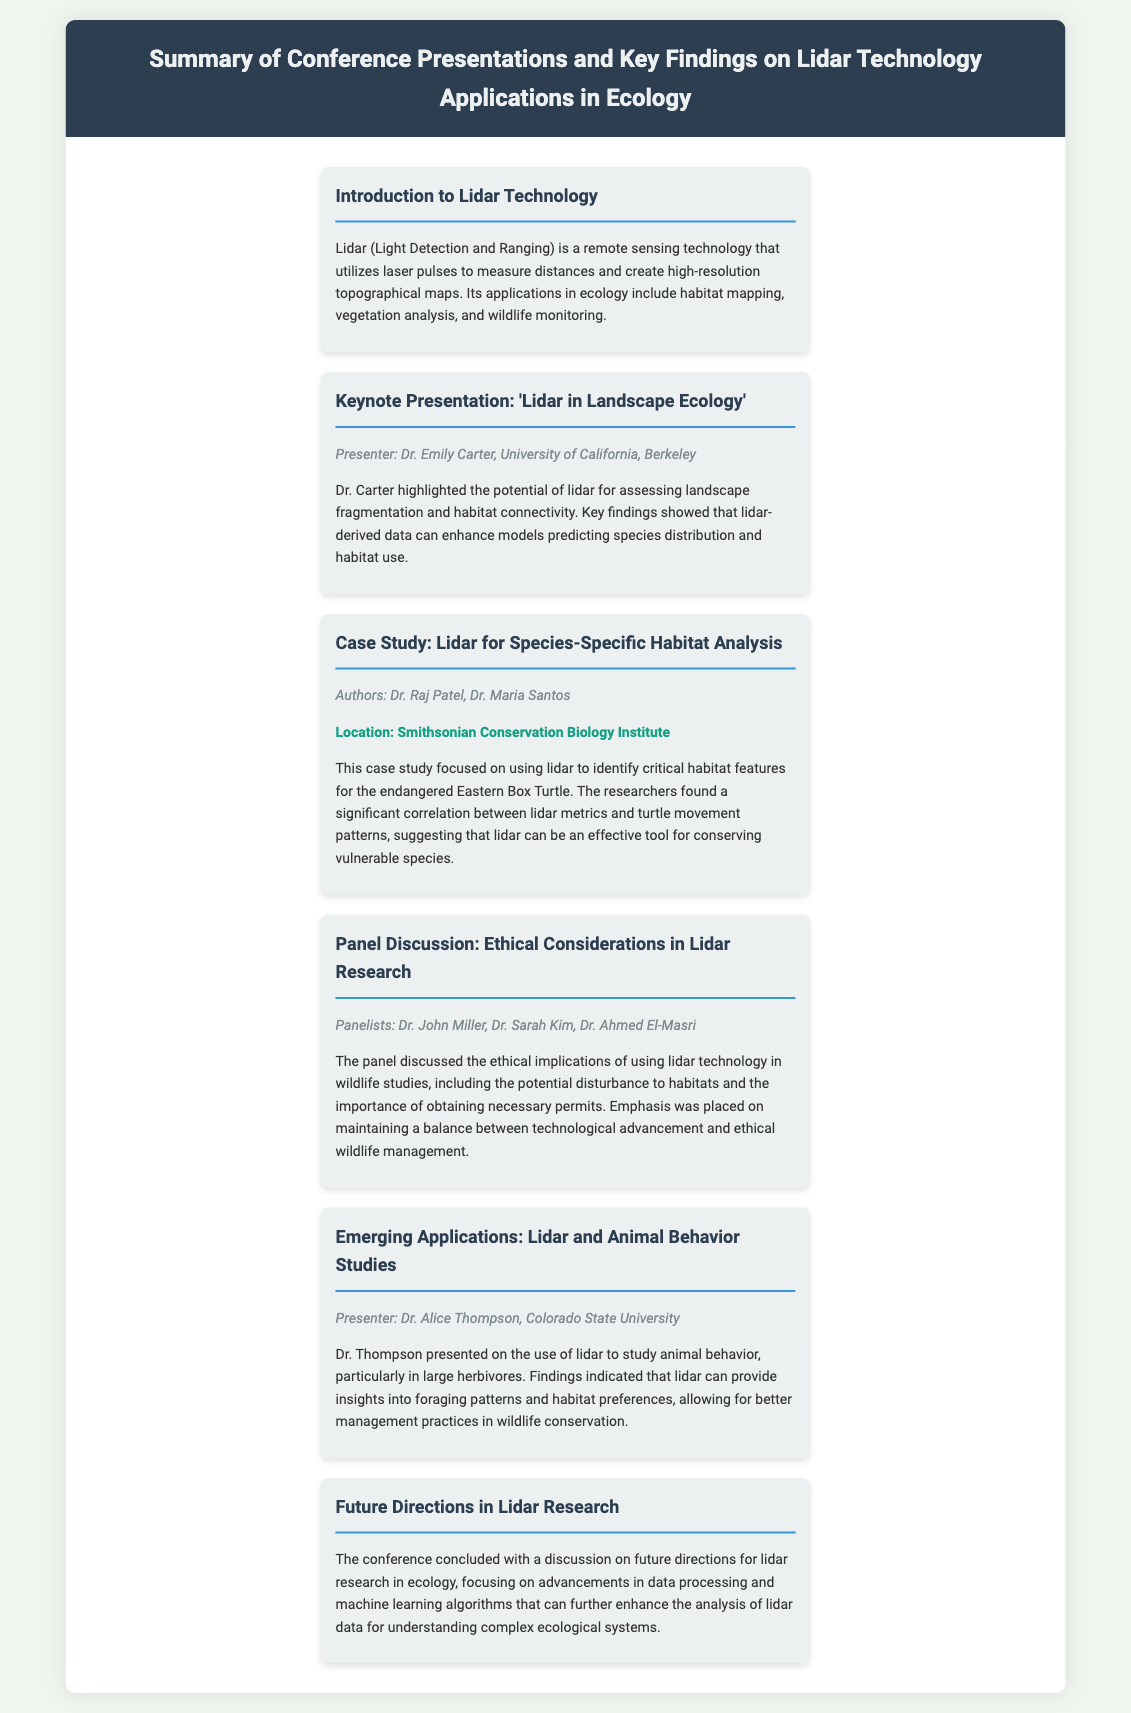What is the primary focus of lidar technology? Lidar technology focuses on remote sensing using laser pulses for various ecological applications, including habitat mapping.
Answer: habitat mapping Who presented the keynote presentation? The keynote presentation was given by Dr. Emily Carter from the University of California, Berkeley.
Answer: Dr. Emily Carter What species was the focus of the case study on habitat analysis? The case study focused on the endangered Eastern Box Turtle.
Answer: Eastern Box Turtle What ethical considerations were discussed in the panel? The panel discussed the ethical implications of using lidar in wildlife studies, particularly the potential disturbance to habitats.
Answer: disturbance to habitats Which university's researcher studied animal behavior using lidar? Dr. Alice Thompson, from Colorado State University, studied animal behavior.
Answer: Colorado State University 